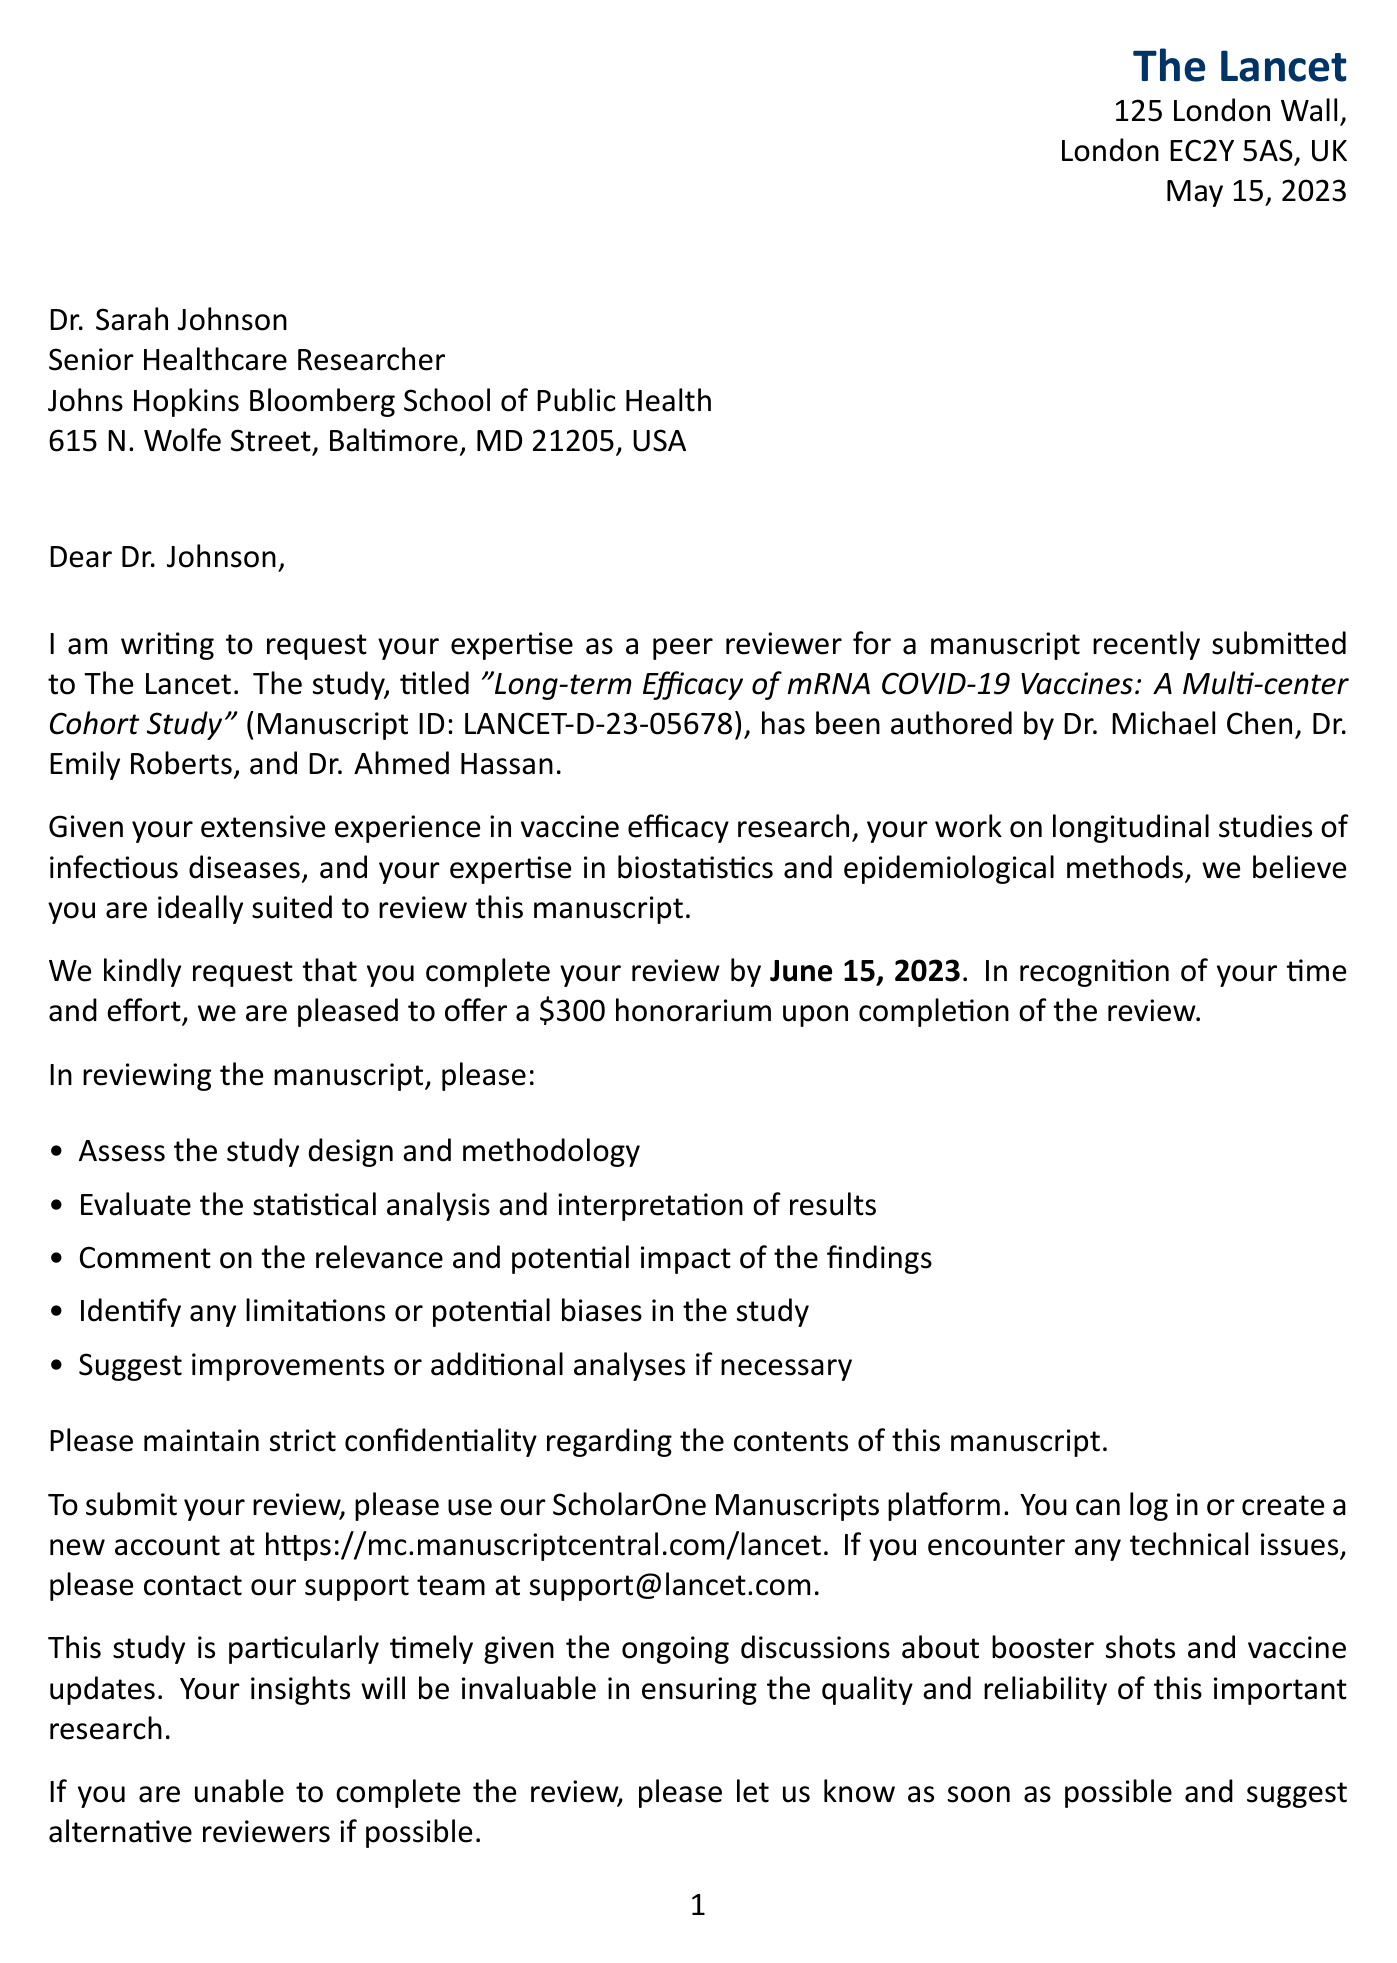What is the name of the journal? The letter is from The Lancet, which is stated in the header.
Answer: The Lancet Who is the recipient of the letter? The recipient is Dr. Sarah Johnson, as indicated in the salutation section of the letter.
Answer: Dr. Sarah Johnson What is the manuscript ID? The manuscript ID is specifically mentioned in the letter to identify the study for review.
Answer: LANCET-D-23-05678 When is the review due? The due date for the review is highlighted in the request details.
Answer: June 15, 2023 What is the honorarium amount offered for the review? The letter states the amount of compensation offered for completing the review.
Answer: $300 What are reviewers expected to assess? The letter lists several criteria that reviewers should consider when evaluating the manuscript.
Answer: Study design and methodology Who authored the study? The authors of the study are mentioned in the document as part of the study details.
Answer: Dr. Michael Chen, Dr. Emily Roberts, Dr. Ahmed Hassan What is the contact email for technical support? The letter provides a specific email for reaching technical support if issues arise.
Answer: support@lancet.com Why is the study considered timely? The letter mentions the context for the study's relevance regarding booster shots and vaccine updates.
Answer: Ongoing discussions about booster shots and vaccine updates 